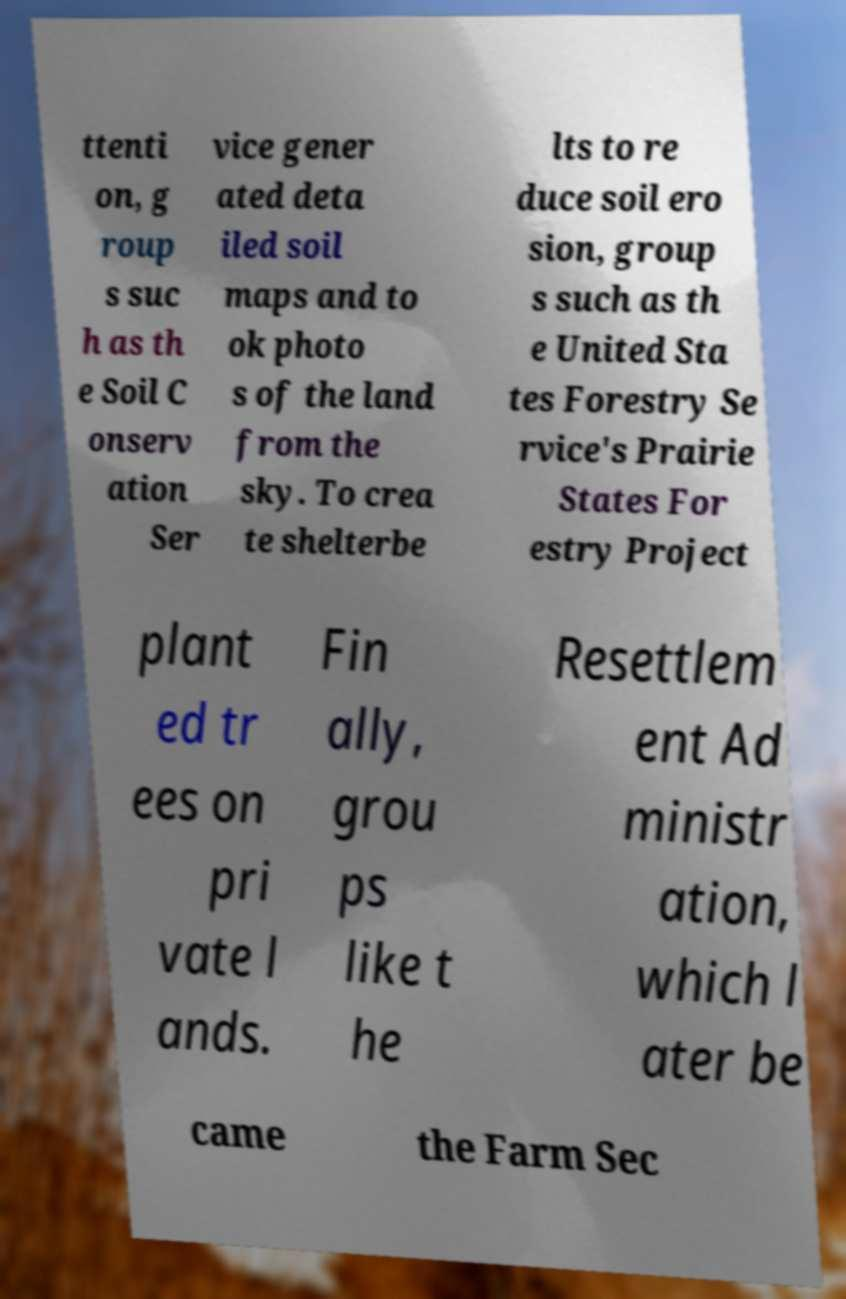Please identify and transcribe the text found in this image. ttenti on, g roup s suc h as th e Soil C onserv ation Ser vice gener ated deta iled soil maps and to ok photo s of the land from the sky. To crea te shelterbe lts to re duce soil ero sion, group s such as th e United Sta tes Forestry Se rvice's Prairie States For estry Project plant ed tr ees on pri vate l ands. Fin ally, grou ps like t he Resettlem ent Ad ministr ation, which l ater be came the Farm Sec 